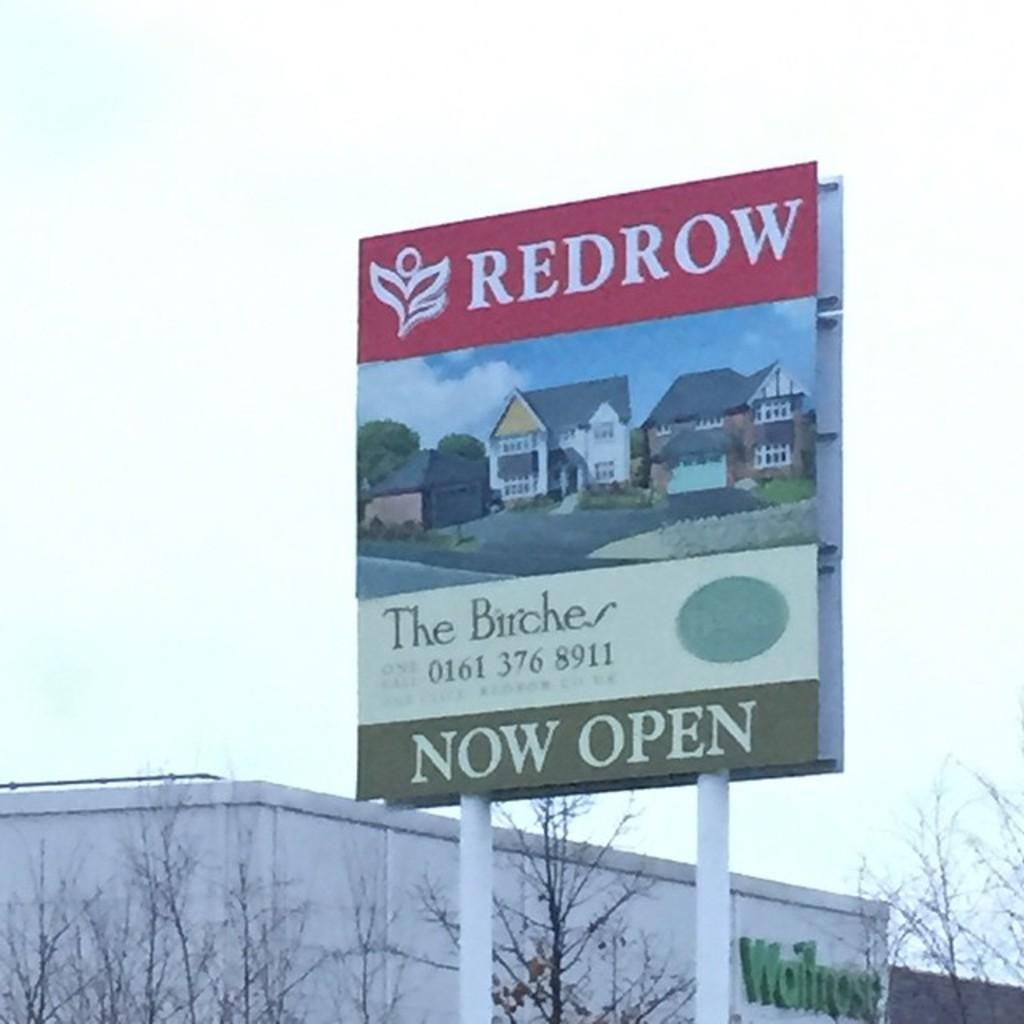<image>
Share a concise interpretation of the image provided. Sign for Redrow saying homes are Now Open. 